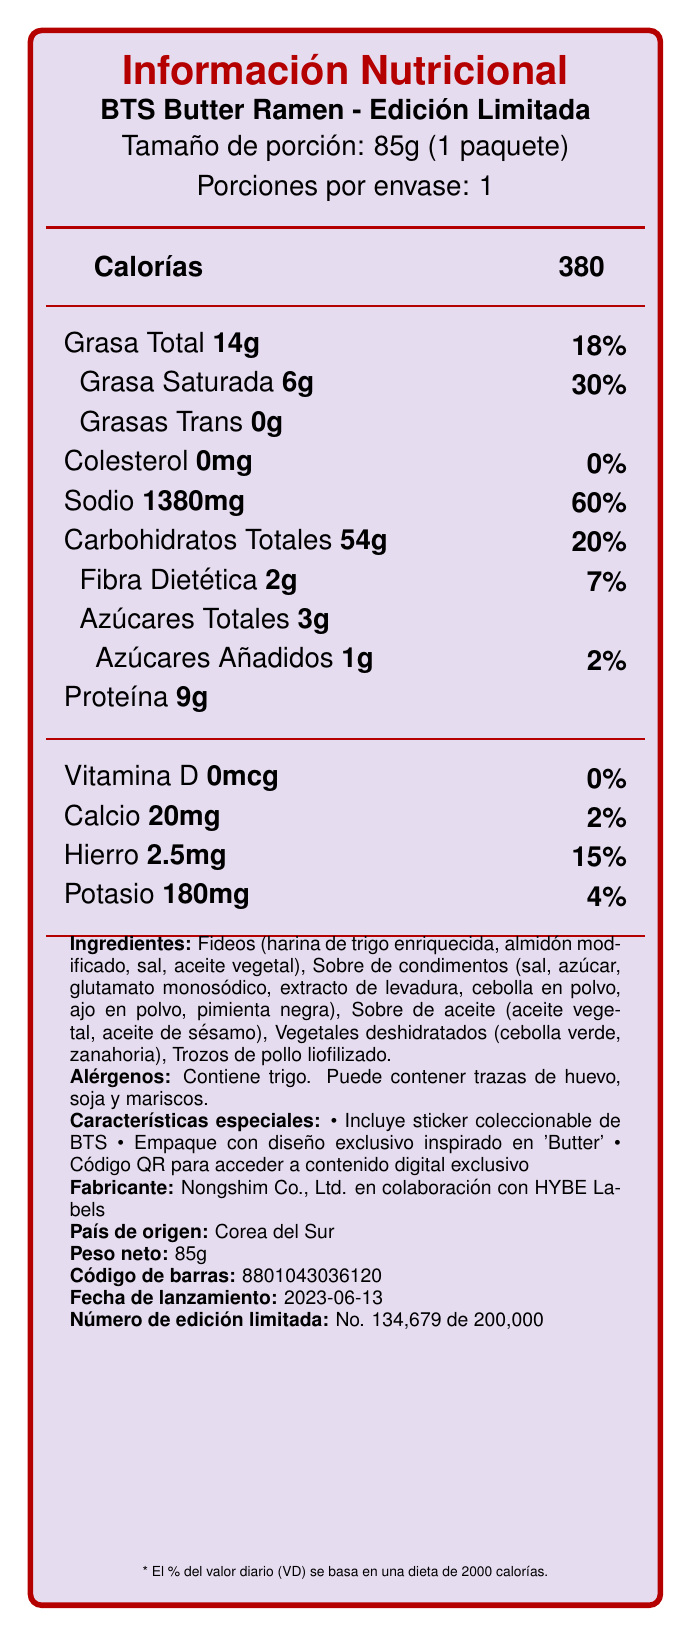what is the product name? The product name is clearly stated at the beginning of the document: "BTS Butter Ramen - Edición Limitada".
Answer: BTS Butter Ramen - Edición Limitada how many calories are in one serving? The calorie content per serving is listed as "Calorías: 380".
Answer: 380 what is the serving size? The serving size is listed as "Tamaño de porción: 85g (1 paquete)".
Answer: 85g what percentage of the daily value of sodium does one serving contain? The percentage of daily value for sodium is listed as "Sodio: 60%".
Answer: 60% what are the main ingredients? The main ingredients are provided in the ingredients section: "Fideos (harina de trigo enriquecida, ...), Sobre de condimentos, Sobre de aceite, Vegetales deshidratados, Trozos de pollo liofilizado".
Answer: Fideos, Sobre de condimentos, Sobre de aceite, Vegetales deshidratados, Trozos de pollo liofilizado what special features does the product include? The special features are listed in the section "Características especiales".
Answer: Incluye sticker coleccionable de BTS, Empaque con diseño exclusivo inspirado en 'Butter', Código QR para acceder a contenido digital exclusivo what is the net weight of the product? The net weight is stated as "Peso neto: 85g".
Answer: 85g how much protein is in a serving? The protein content per serving is listed as "Proteína: 9g".
Answer: 9g what is the release date of the product? The release date is listed as "Fecha de lanzamiento: 2023-06-13".
Answer: 2023-06-13 which country is the product from? A. Japan B. China C. South Korea The country of origin is stated as "País de origen: Corea del Sur".
Answer: C. South Korea what is the total fat content per serving? A. 14g B. 6g C. 30g D. 18g The total fat content per serving is listed as "Grasa Total: 14g".
Answer: A. 14g how many servings are there per container? The document states "Porciones por envase: 1".
Answer: 1 how much dietary fiber does one serving contain? The dietary fiber content per serving is listed as "Fibra Dietética: 2g".
Answer: 2g does the product contain vitamin D? The document states "Vitamina D: 0mcg" which means there is no vitamin D.
Answer: No is there any cholesterol in the product? The document states "Colesterol: 0mg", indicating there is no cholesterol.
Answer: No what is the barcode number? The barcode number is listed as "Código de barras: 8801043036120".
Answer: 8801043036120 how should the product be stored? The storage instructions are given as "Conservar en un lugar fresco y seco".
Answer: Conservar en un lugar fresco y seco who is the manufacturer? The manufacturer is listed as "Nongshim Co., Ltd. en colaboración con HYBE Labels".
Answer: Nongshim Co., Ltd. en colaboración con HYBE Labels what is the limited edition number? The limited edition number is stated as "Número de edición limitada: No. 134,679 de 200,000".
Answer: No. 134,679 de 200,000 describe the nutritional information of the product This summary covers the main nutritional components displayed in the document, listing out the values and daily percentages.
Answer: The BTS Butter Ramen - Edición Limitada contains 380 calories per serving. It includes 14g of total fat (18% DV), 6g of saturated fat (30% DV), 0g of trans fat, 0mg of cholesterol (0% DV), and 1380mg of sodium (60% DV). The carbohydrates total 54g (20% DV) with 2g of dietary fiber (7% DV) and 3g of total sugars (including 1g of added sugars which is 2% DV). The protein content is 9g. It also contains minor amounts of vitamin D (0mcg, 0% DV), calcium (20mg, 2% DV), iron (2.5mg, 15% DV), and potassium (180mg, 4% DV). why does the product have such high sodium content? The document provides the sodium content but does not explain why it is high.
Answer: Cannot be determined 